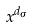Convert formula to latex. <formula><loc_0><loc_0><loc_500><loc_500>x ^ { d _ { \sigma } }</formula> 